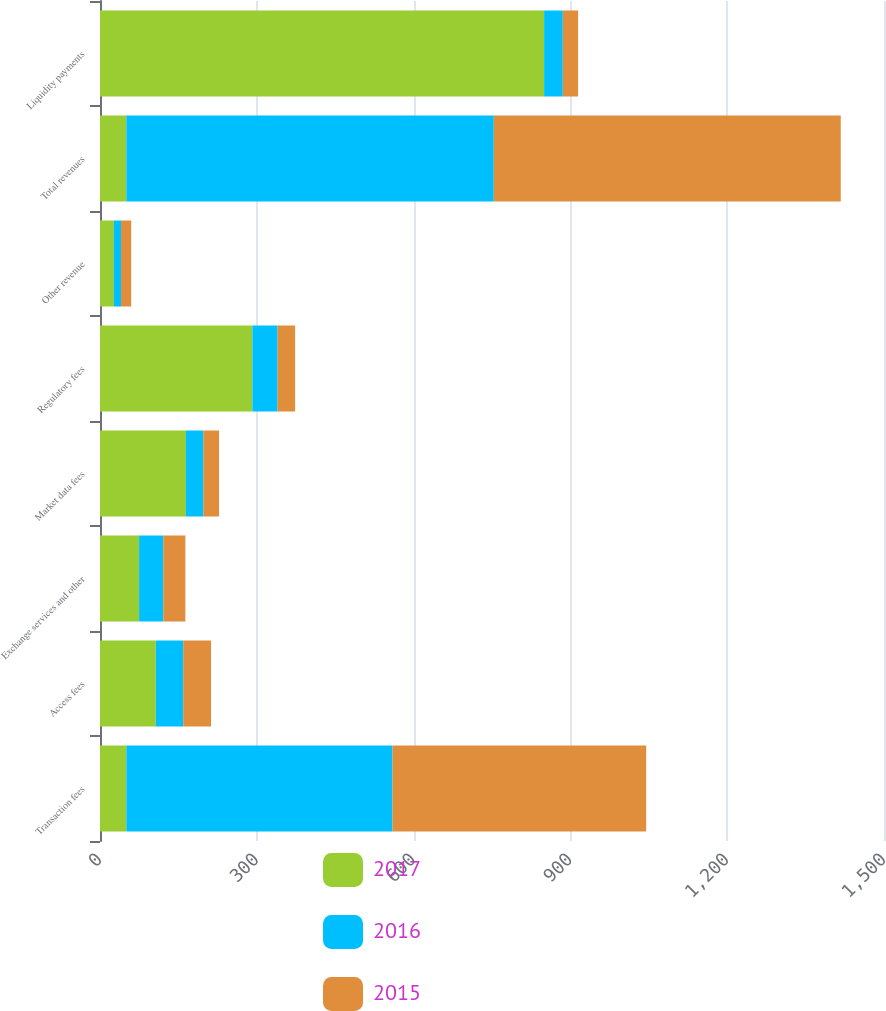Convert chart to OTSL. <chart><loc_0><loc_0><loc_500><loc_500><stacked_bar_chart><ecel><fcel>Transaction fees<fcel>Access fees<fcel>Exchange services and other<fcel>Market data fees<fcel>Regulatory fees<fcel>Other revenue<fcel>Total revenues<fcel>Liquidity payments<nl><fcel>2017<fcel>50.35<fcel>106.8<fcel>74.8<fcel>164.5<fcel>291.5<fcel>26.6<fcel>50.35<fcel>849.7<nl><fcel>2016<fcel>509.3<fcel>52.4<fcel>46.3<fcel>33.2<fcel>48.3<fcel>13.6<fcel>703.1<fcel>35.8<nl><fcel>2015<fcel>485.3<fcel>53.3<fcel>42.2<fcel>30<fcel>33.5<fcel>19.5<fcel>663.8<fcel>29.2<nl></chart> 